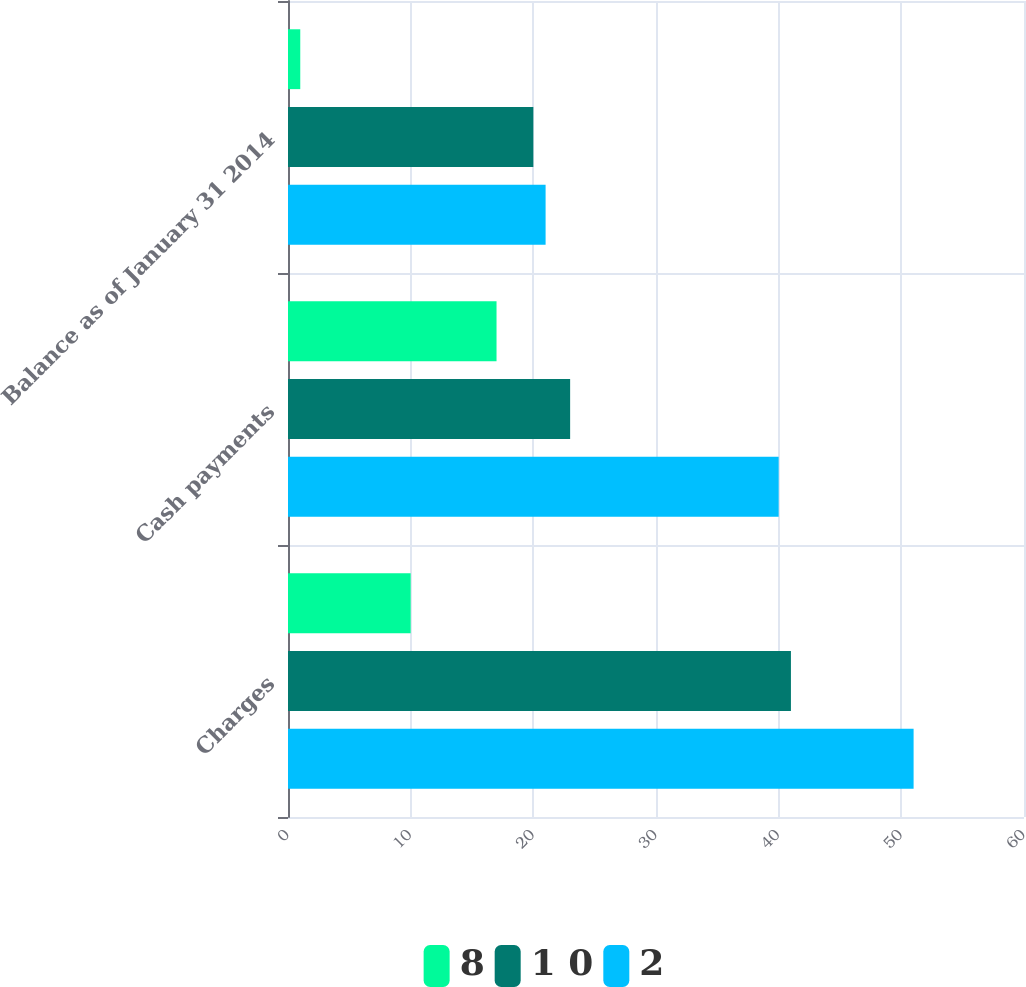<chart> <loc_0><loc_0><loc_500><loc_500><stacked_bar_chart><ecel><fcel>Charges<fcel>Cash payments<fcel>Balance as of January 31 2014<nl><fcel>8<fcel>10<fcel>17<fcel>1<nl><fcel>1 0<fcel>41<fcel>23<fcel>20<nl><fcel>2<fcel>51<fcel>40<fcel>21<nl></chart> 